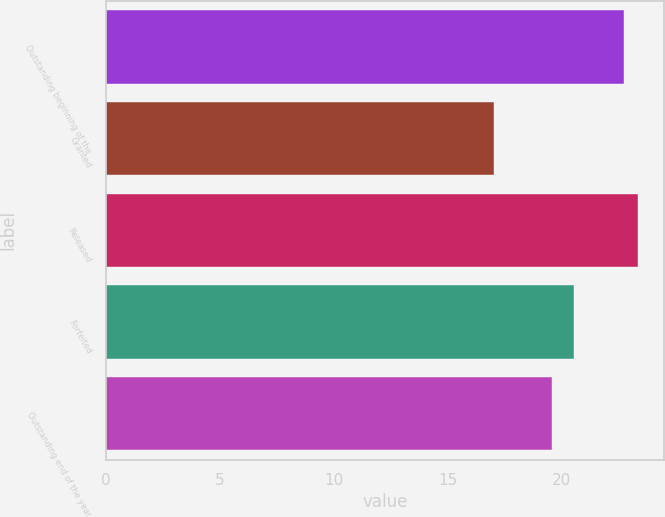<chart> <loc_0><loc_0><loc_500><loc_500><bar_chart><fcel>Outstanding beginning of the<fcel>Granted<fcel>Released<fcel>Forfeited<fcel>Outstanding end of the year<nl><fcel>22.73<fcel>17.04<fcel>23.32<fcel>20.52<fcel>19.55<nl></chart> 